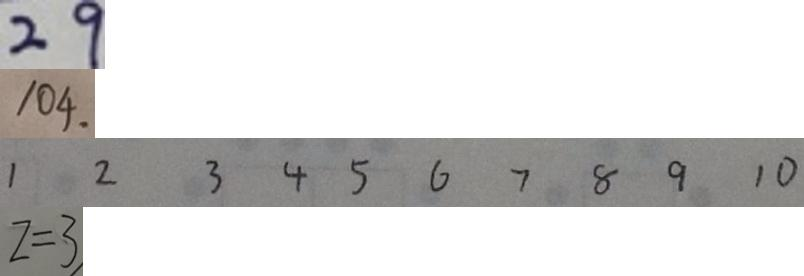<formula> <loc_0><loc_0><loc_500><loc_500>2 9 
 1 0 4 . 
 1 2 3 4 5 6 7 8 9 1 0 
 z = 3</formula> 